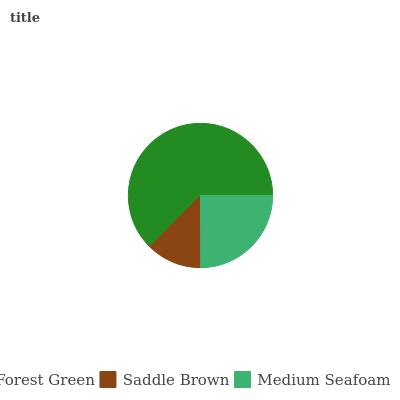Is Saddle Brown the minimum?
Answer yes or no. Yes. Is Forest Green the maximum?
Answer yes or no. Yes. Is Medium Seafoam the minimum?
Answer yes or no. No. Is Medium Seafoam the maximum?
Answer yes or no. No. Is Medium Seafoam greater than Saddle Brown?
Answer yes or no. Yes. Is Saddle Brown less than Medium Seafoam?
Answer yes or no. Yes. Is Saddle Brown greater than Medium Seafoam?
Answer yes or no. No. Is Medium Seafoam less than Saddle Brown?
Answer yes or no. No. Is Medium Seafoam the high median?
Answer yes or no. Yes. Is Medium Seafoam the low median?
Answer yes or no. Yes. Is Forest Green the high median?
Answer yes or no. No. Is Saddle Brown the low median?
Answer yes or no. No. 